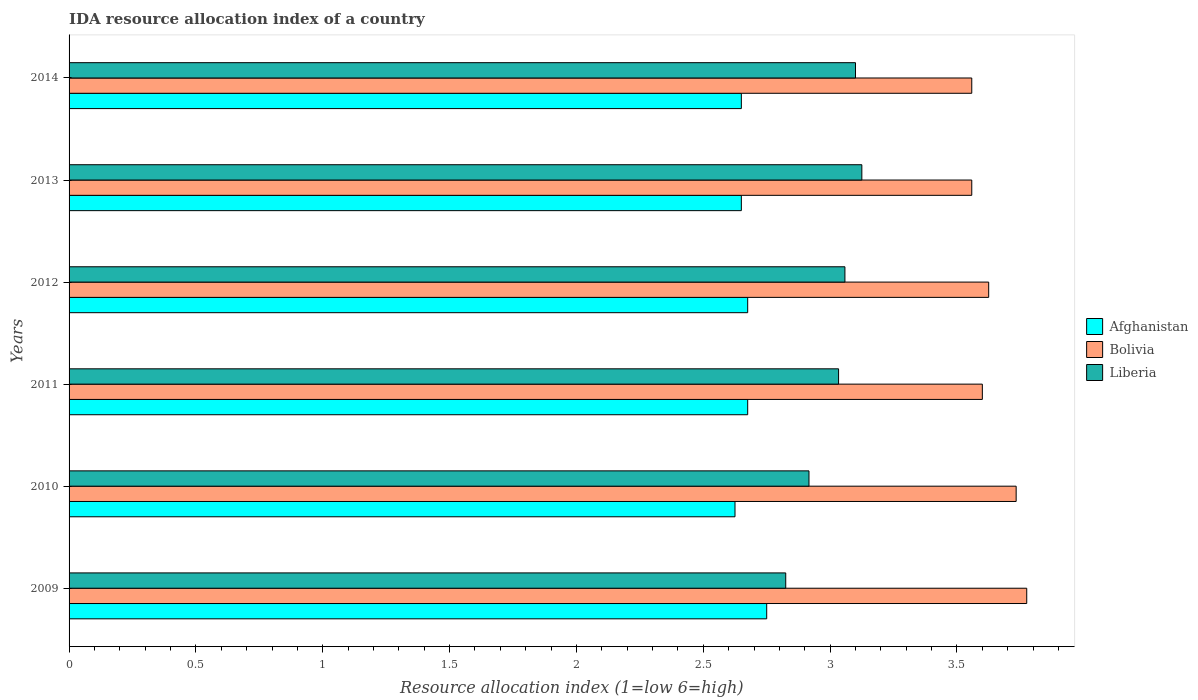How many different coloured bars are there?
Offer a terse response. 3. Are the number of bars per tick equal to the number of legend labels?
Make the answer very short. Yes. How many bars are there on the 2nd tick from the bottom?
Provide a short and direct response. 3. What is the label of the 1st group of bars from the top?
Offer a terse response. 2014. What is the IDA resource allocation index in Bolivia in 2009?
Give a very brief answer. 3.77. Across all years, what is the maximum IDA resource allocation index in Afghanistan?
Ensure brevity in your answer.  2.75. Across all years, what is the minimum IDA resource allocation index in Bolivia?
Your answer should be very brief. 3.56. In which year was the IDA resource allocation index in Bolivia maximum?
Make the answer very short. 2009. In which year was the IDA resource allocation index in Liberia minimum?
Make the answer very short. 2009. What is the total IDA resource allocation index in Liberia in the graph?
Provide a short and direct response. 18.06. What is the difference between the IDA resource allocation index in Afghanistan in 2009 and that in 2012?
Give a very brief answer. 0.08. What is the difference between the IDA resource allocation index in Liberia in 2014 and the IDA resource allocation index in Afghanistan in 2013?
Offer a terse response. 0.45. What is the average IDA resource allocation index in Bolivia per year?
Offer a terse response. 3.64. In the year 2014, what is the difference between the IDA resource allocation index in Liberia and IDA resource allocation index in Afghanistan?
Your response must be concise. 0.45. What is the ratio of the IDA resource allocation index in Liberia in 2011 to that in 2014?
Offer a very short reply. 0.98. Is the IDA resource allocation index in Bolivia in 2012 less than that in 2014?
Keep it short and to the point. No. What is the difference between the highest and the second highest IDA resource allocation index in Liberia?
Offer a terse response. 0.02. What is the difference between the highest and the lowest IDA resource allocation index in Bolivia?
Offer a terse response. 0.22. In how many years, is the IDA resource allocation index in Afghanistan greater than the average IDA resource allocation index in Afghanistan taken over all years?
Ensure brevity in your answer.  3. What does the 1st bar from the top in 2009 represents?
Ensure brevity in your answer.  Liberia. What does the 3rd bar from the bottom in 2013 represents?
Provide a succinct answer. Liberia. Is it the case that in every year, the sum of the IDA resource allocation index in Liberia and IDA resource allocation index in Afghanistan is greater than the IDA resource allocation index in Bolivia?
Your answer should be very brief. Yes. How many bars are there?
Keep it short and to the point. 18. How many years are there in the graph?
Provide a short and direct response. 6. Are the values on the major ticks of X-axis written in scientific E-notation?
Your answer should be compact. No. Does the graph contain any zero values?
Keep it short and to the point. No. Does the graph contain grids?
Ensure brevity in your answer.  No. Where does the legend appear in the graph?
Your answer should be compact. Center right. How are the legend labels stacked?
Offer a very short reply. Vertical. What is the title of the graph?
Keep it short and to the point. IDA resource allocation index of a country. Does "Switzerland" appear as one of the legend labels in the graph?
Provide a short and direct response. No. What is the label or title of the X-axis?
Make the answer very short. Resource allocation index (1=low 6=high). What is the Resource allocation index (1=low 6=high) in Afghanistan in 2009?
Keep it short and to the point. 2.75. What is the Resource allocation index (1=low 6=high) of Bolivia in 2009?
Your response must be concise. 3.77. What is the Resource allocation index (1=low 6=high) in Liberia in 2009?
Your answer should be very brief. 2.83. What is the Resource allocation index (1=low 6=high) of Afghanistan in 2010?
Provide a short and direct response. 2.62. What is the Resource allocation index (1=low 6=high) in Bolivia in 2010?
Your response must be concise. 3.73. What is the Resource allocation index (1=low 6=high) in Liberia in 2010?
Offer a terse response. 2.92. What is the Resource allocation index (1=low 6=high) of Afghanistan in 2011?
Keep it short and to the point. 2.67. What is the Resource allocation index (1=low 6=high) of Liberia in 2011?
Your response must be concise. 3.03. What is the Resource allocation index (1=low 6=high) of Afghanistan in 2012?
Provide a succinct answer. 2.67. What is the Resource allocation index (1=low 6=high) in Bolivia in 2012?
Provide a short and direct response. 3.62. What is the Resource allocation index (1=low 6=high) of Liberia in 2012?
Provide a succinct answer. 3.06. What is the Resource allocation index (1=low 6=high) in Afghanistan in 2013?
Provide a succinct answer. 2.65. What is the Resource allocation index (1=low 6=high) of Bolivia in 2013?
Offer a very short reply. 3.56. What is the Resource allocation index (1=low 6=high) of Liberia in 2013?
Give a very brief answer. 3.12. What is the Resource allocation index (1=low 6=high) of Afghanistan in 2014?
Provide a succinct answer. 2.65. What is the Resource allocation index (1=low 6=high) of Bolivia in 2014?
Your response must be concise. 3.56. Across all years, what is the maximum Resource allocation index (1=low 6=high) in Afghanistan?
Ensure brevity in your answer.  2.75. Across all years, what is the maximum Resource allocation index (1=low 6=high) in Bolivia?
Keep it short and to the point. 3.77. Across all years, what is the maximum Resource allocation index (1=low 6=high) in Liberia?
Offer a very short reply. 3.12. Across all years, what is the minimum Resource allocation index (1=low 6=high) in Afghanistan?
Your answer should be very brief. 2.62. Across all years, what is the minimum Resource allocation index (1=low 6=high) of Bolivia?
Keep it short and to the point. 3.56. Across all years, what is the minimum Resource allocation index (1=low 6=high) in Liberia?
Your response must be concise. 2.83. What is the total Resource allocation index (1=low 6=high) of Afghanistan in the graph?
Provide a short and direct response. 16.02. What is the total Resource allocation index (1=low 6=high) in Bolivia in the graph?
Offer a terse response. 21.85. What is the total Resource allocation index (1=low 6=high) in Liberia in the graph?
Provide a short and direct response. 18.06. What is the difference between the Resource allocation index (1=low 6=high) in Bolivia in 2009 and that in 2010?
Offer a terse response. 0.04. What is the difference between the Resource allocation index (1=low 6=high) of Liberia in 2009 and that in 2010?
Offer a terse response. -0.09. What is the difference between the Resource allocation index (1=low 6=high) in Afghanistan in 2009 and that in 2011?
Your answer should be compact. 0.07. What is the difference between the Resource allocation index (1=low 6=high) of Bolivia in 2009 and that in 2011?
Your answer should be very brief. 0.17. What is the difference between the Resource allocation index (1=low 6=high) in Liberia in 2009 and that in 2011?
Keep it short and to the point. -0.21. What is the difference between the Resource allocation index (1=low 6=high) in Afghanistan in 2009 and that in 2012?
Offer a very short reply. 0.07. What is the difference between the Resource allocation index (1=low 6=high) in Bolivia in 2009 and that in 2012?
Ensure brevity in your answer.  0.15. What is the difference between the Resource allocation index (1=low 6=high) in Liberia in 2009 and that in 2012?
Your answer should be very brief. -0.23. What is the difference between the Resource allocation index (1=low 6=high) in Afghanistan in 2009 and that in 2013?
Provide a succinct answer. 0.1. What is the difference between the Resource allocation index (1=low 6=high) in Bolivia in 2009 and that in 2013?
Your answer should be very brief. 0.22. What is the difference between the Resource allocation index (1=low 6=high) in Liberia in 2009 and that in 2013?
Offer a very short reply. -0.3. What is the difference between the Resource allocation index (1=low 6=high) in Bolivia in 2009 and that in 2014?
Your response must be concise. 0.22. What is the difference between the Resource allocation index (1=low 6=high) of Liberia in 2009 and that in 2014?
Offer a terse response. -0.28. What is the difference between the Resource allocation index (1=low 6=high) in Bolivia in 2010 and that in 2011?
Offer a very short reply. 0.13. What is the difference between the Resource allocation index (1=low 6=high) of Liberia in 2010 and that in 2011?
Your response must be concise. -0.12. What is the difference between the Resource allocation index (1=low 6=high) in Afghanistan in 2010 and that in 2012?
Your answer should be very brief. -0.05. What is the difference between the Resource allocation index (1=low 6=high) in Bolivia in 2010 and that in 2012?
Give a very brief answer. 0.11. What is the difference between the Resource allocation index (1=low 6=high) in Liberia in 2010 and that in 2012?
Keep it short and to the point. -0.14. What is the difference between the Resource allocation index (1=low 6=high) in Afghanistan in 2010 and that in 2013?
Offer a very short reply. -0.03. What is the difference between the Resource allocation index (1=low 6=high) in Bolivia in 2010 and that in 2013?
Give a very brief answer. 0.17. What is the difference between the Resource allocation index (1=low 6=high) in Liberia in 2010 and that in 2013?
Offer a terse response. -0.21. What is the difference between the Resource allocation index (1=low 6=high) of Afghanistan in 2010 and that in 2014?
Give a very brief answer. -0.03. What is the difference between the Resource allocation index (1=low 6=high) in Bolivia in 2010 and that in 2014?
Your answer should be very brief. 0.17. What is the difference between the Resource allocation index (1=low 6=high) in Liberia in 2010 and that in 2014?
Offer a very short reply. -0.18. What is the difference between the Resource allocation index (1=low 6=high) of Afghanistan in 2011 and that in 2012?
Keep it short and to the point. 0. What is the difference between the Resource allocation index (1=low 6=high) in Bolivia in 2011 and that in 2012?
Provide a succinct answer. -0.03. What is the difference between the Resource allocation index (1=low 6=high) in Liberia in 2011 and that in 2012?
Give a very brief answer. -0.03. What is the difference between the Resource allocation index (1=low 6=high) in Afghanistan in 2011 and that in 2013?
Ensure brevity in your answer.  0.03. What is the difference between the Resource allocation index (1=low 6=high) of Bolivia in 2011 and that in 2013?
Your answer should be very brief. 0.04. What is the difference between the Resource allocation index (1=low 6=high) in Liberia in 2011 and that in 2013?
Provide a short and direct response. -0.09. What is the difference between the Resource allocation index (1=low 6=high) in Afghanistan in 2011 and that in 2014?
Make the answer very short. 0.03. What is the difference between the Resource allocation index (1=low 6=high) in Bolivia in 2011 and that in 2014?
Give a very brief answer. 0.04. What is the difference between the Resource allocation index (1=low 6=high) of Liberia in 2011 and that in 2014?
Your answer should be very brief. -0.07. What is the difference between the Resource allocation index (1=low 6=high) of Afghanistan in 2012 and that in 2013?
Your response must be concise. 0.03. What is the difference between the Resource allocation index (1=low 6=high) of Bolivia in 2012 and that in 2013?
Your answer should be very brief. 0.07. What is the difference between the Resource allocation index (1=low 6=high) of Liberia in 2012 and that in 2013?
Keep it short and to the point. -0.07. What is the difference between the Resource allocation index (1=low 6=high) in Afghanistan in 2012 and that in 2014?
Your answer should be very brief. 0.03. What is the difference between the Resource allocation index (1=low 6=high) in Bolivia in 2012 and that in 2014?
Provide a succinct answer. 0.07. What is the difference between the Resource allocation index (1=low 6=high) of Liberia in 2012 and that in 2014?
Your answer should be compact. -0.04. What is the difference between the Resource allocation index (1=low 6=high) of Afghanistan in 2013 and that in 2014?
Give a very brief answer. 0. What is the difference between the Resource allocation index (1=low 6=high) in Liberia in 2013 and that in 2014?
Make the answer very short. 0.03. What is the difference between the Resource allocation index (1=low 6=high) in Afghanistan in 2009 and the Resource allocation index (1=low 6=high) in Bolivia in 2010?
Offer a terse response. -0.98. What is the difference between the Resource allocation index (1=low 6=high) of Afghanistan in 2009 and the Resource allocation index (1=low 6=high) of Liberia in 2010?
Your answer should be compact. -0.17. What is the difference between the Resource allocation index (1=low 6=high) in Bolivia in 2009 and the Resource allocation index (1=low 6=high) in Liberia in 2010?
Make the answer very short. 0.86. What is the difference between the Resource allocation index (1=low 6=high) in Afghanistan in 2009 and the Resource allocation index (1=low 6=high) in Bolivia in 2011?
Ensure brevity in your answer.  -0.85. What is the difference between the Resource allocation index (1=low 6=high) in Afghanistan in 2009 and the Resource allocation index (1=low 6=high) in Liberia in 2011?
Keep it short and to the point. -0.28. What is the difference between the Resource allocation index (1=low 6=high) in Bolivia in 2009 and the Resource allocation index (1=low 6=high) in Liberia in 2011?
Make the answer very short. 0.74. What is the difference between the Resource allocation index (1=low 6=high) in Afghanistan in 2009 and the Resource allocation index (1=low 6=high) in Bolivia in 2012?
Offer a terse response. -0.88. What is the difference between the Resource allocation index (1=low 6=high) of Afghanistan in 2009 and the Resource allocation index (1=low 6=high) of Liberia in 2012?
Provide a short and direct response. -0.31. What is the difference between the Resource allocation index (1=low 6=high) of Bolivia in 2009 and the Resource allocation index (1=low 6=high) of Liberia in 2012?
Provide a short and direct response. 0.72. What is the difference between the Resource allocation index (1=low 6=high) in Afghanistan in 2009 and the Resource allocation index (1=low 6=high) in Bolivia in 2013?
Offer a very short reply. -0.81. What is the difference between the Resource allocation index (1=low 6=high) of Afghanistan in 2009 and the Resource allocation index (1=low 6=high) of Liberia in 2013?
Keep it short and to the point. -0.38. What is the difference between the Resource allocation index (1=low 6=high) of Bolivia in 2009 and the Resource allocation index (1=low 6=high) of Liberia in 2013?
Your answer should be very brief. 0.65. What is the difference between the Resource allocation index (1=low 6=high) in Afghanistan in 2009 and the Resource allocation index (1=low 6=high) in Bolivia in 2014?
Your answer should be very brief. -0.81. What is the difference between the Resource allocation index (1=low 6=high) of Afghanistan in 2009 and the Resource allocation index (1=low 6=high) of Liberia in 2014?
Offer a very short reply. -0.35. What is the difference between the Resource allocation index (1=low 6=high) of Bolivia in 2009 and the Resource allocation index (1=low 6=high) of Liberia in 2014?
Your answer should be very brief. 0.68. What is the difference between the Resource allocation index (1=low 6=high) of Afghanistan in 2010 and the Resource allocation index (1=low 6=high) of Bolivia in 2011?
Provide a short and direct response. -0.97. What is the difference between the Resource allocation index (1=low 6=high) in Afghanistan in 2010 and the Resource allocation index (1=low 6=high) in Liberia in 2011?
Your answer should be very brief. -0.41. What is the difference between the Resource allocation index (1=low 6=high) in Bolivia in 2010 and the Resource allocation index (1=low 6=high) in Liberia in 2011?
Your answer should be compact. 0.7. What is the difference between the Resource allocation index (1=low 6=high) in Afghanistan in 2010 and the Resource allocation index (1=low 6=high) in Liberia in 2012?
Keep it short and to the point. -0.43. What is the difference between the Resource allocation index (1=low 6=high) in Bolivia in 2010 and the Resource allocation index (1=low 6=high) in Liberia in 2012?
Provide a short and direct response. 0.68. What is the difference between the Resource allocation index (1=low 6=high) in Afghanistan in 2010 and the Resource allocation index (1=low 6=high) in Bolivia in 2013?
Your answer should be very brief. -0.93. What is the difference between the Resource allocation index (1=low 6=high) in Afghanistan in 2010 and the Resource allocation index (1=low 6=high) in Liberia in 2013?
Provide a succinct answer. -0.5. What is the difference between the Resource allocation index (1=low 6=high) of Bolivia in 2010 and the Resource allocation index (1=low 6=high) of Liberia in 2013?
Your answer should be very brief. 0.61. What is the difference between the Resource allocation index (1=low 6=high) of Afghanistan in 2010 and the Resource allocation index (1=low 6=high) of Bolivia in 2014?
Make the answer very short. -0.93. What is the difference between the Resource allocation index (1=low 6=high) in Afghanistan in 2010 and the Resource allocation index (1=low 6=high) in Liberia in 2014?
Your answer should be compact. -0.47. What is the difference between the Resource allocation index (1=low 6=high) of Bolivia in 2010 and the Resource allocation index (1=low 6=high) of Liberia in 2014?
Your answer should be very brief. 0.63. What is the difference between the Resource allocation index (1=low 6=high) in Afghanistan in 2011 and the Resource allocation index (1=low 6=high) in Bolivia in 2012?
Offer a very short reply. -0.95. What is the difference between the Resource allocation index (1=low 6=high) in Afghanistan in 2011 and the Resource allocation index (1=low 6=high) in Liberia in 2012?
Offer a very short reply. -0.38. What is the difference between the Resource allocation index (1=low 6=high) in Bolivia in 2011 and the Resource allocation index (1=low 6=high) in Liberia in 2012?
Keep it short and to the point. 0.54. What is the difference between the Resource allocation index (1=low 6=high) of Afghanistan in 2011 and the Resource allocation index (1=low 6=high) of Bolivia in 2013?
Your response must be concise. -0.88. What is the difference between the Resource allocation index (1=low 6=high) in Afghanistan in 2011 and the Resource allocation index (1=low 6=high) in Liberia in 2013?
Offer a terse response. -0.45. What is the difference between the Resource allocation index (1=low 6=high) in Bolivia in 2011 and the Resource allocation index (1=low 6=high) in Liberia in 2013?
Ensure brevity in your answer.  0.47. What is the difference between the Resource allocation index (1=low 6=high) in Afghanistan in 2011 and the Resource allocation index (1=low 6=high) in Bolivia in 2014?
Ensure brevity in your answer.  -0.88. What is the difference between the Resource allocation index (1=low 6=high) of Afghanistan in 2011 and the Resource allocation index (1=low 6=high) of Liberia in 2014?
Keep it short and to the point. -0.42. What is the difference between the Resource allocation index (1=low 6=high) in Afghanistan in 2012 and the Resource allocation index (1=low 6=high) in Bolivia in 2013?
Make the answer very short. -0.88. What is the difference between the Resource allocation index (1=low 6=high) of Afghanistan in 2012 and the Resource allocation index (1=low 6=high) of Liberia in 2013?
Offer a very short reply. -0.45. What is the difference between the Resource allocation index (1=low 6=high) of Bolivia in 2012 and the Resource allocation index (1=low 6=high) of Liberia in 2013?
Your response must be concise. 0.5. What is the difference between the Resource allocation index (1=low 6=high) in Afghanistan in 2012 and the Resource allocation index (1=low 6=high) in Bolivia in 2014?
Make the answer very short. -0.88. What is the difference between the Resource allocation index (1=low 6=high) of Afghanistan in 2012 and the Resource allocation index (1=low 6=high) of Liberia in 2014?
Your answer should be very brief. -0.42. What is the difference between the Resource allocation index (1=low 6=high) of Bolivia in 2012 and the Resource allocation index (1=low 6=high) of Liberia in 2014?
Ensure brevity in your answer.  0.53. What is the difference between the Resource allocation index (1=low 6=high) in Afghanistan in 2013 and the Resource allocation index (1=low 6=high) in Bolivia in 2014?
Offer a terse response. -0.91. What is the difference between the Resource allocation index (1=low 6=high) of Afghanistan in 2013 and the Resource allocation index (1=low 6=high) of Liberia in 2014?
Ensure brevity in your answer.  -0.45. What is the difference between the Resource allocation index (1=low 6=high) of Bolivia in 2013 and the Resource allocation index (1=low 6=high) of Liberia in 2014?
Provide a succinct answer. 0.46. What is the average Resource allocation index (1=low 6=high) in Afghanistan per year?
Offer a very short reply. 2.67. What is the average Resource allocation index (1=low 6=high) in Bolivia per year?
Provide a short and direct response. 3.64. What is the average Resource allocation index (1=low 6=high) in Liberia per year?
Ensure brevity in your answer.  3.01. In the year 2009, what is the difference between the Resource allocation index (1=low 6=high) in Afghanistan and Resource allocation index (1=low 6=high) in Bolivia?
Ensure brevity in your answer.  -1.02. In the year 2009, what is the difference between the Resource allocation index (1=low 6=high) in Afghanistan and Resource allocation index (1=low 6=high) in Liberia?
Keep it short and to the point. -0.07. In the year 2010, what is the difference between the Resource allocation index (1=low 6=high) in Afghanistan and Resource allocation index (1=low 6=high) in Bolivia?
Give a very brief answer. -1.11. In the year 2010, what is the difference between the Resource allocation index (1=low 6=high) of Afghanistan and Resource allocation index (1=low 6=high) of Liberia?
Provide a short and direct response. -0.29. In the year 2010, what is the difference between the Resource allocation index (1=low 6=high) in Bolivia and Resource allocation index (1=low 6=high) in Liberia?
Offer a very short reply. 0.82. In the year 2011, what is the difference between the Resource allocation index (1=low 6=high) of Afghanistan and Resource allocation index (1=low 6=high) of Bolivia?
Ensure brevity in your answer.  -0.93. In the year 2011, what is the difference between the Resource allocation index (1=low 6=high) of Afghanistan and Resource allocation index (1=low 6=high) of Liberia?
Your response must be concise. -0.36. In the year 2011, what is the difference between the Resource allocation index (1=low 6=high) in Bolivia and Resource allocation index (1=low 6=high) in Liberia?
Give a very brief answer. 0.57. In the year 2012, what is the difference between the Resource allocation index (1=low 6=high) of Afghanistan and Resource allocation index (1=low 6=high) of Bolivia?
Ensure brevity in your answer.  -0.95. In the year 2012, what is the difference between the Resource allocation index (1=low 6=high) of Afghanistan and Resource allocation index (1=low 6=high) of Liberia?
Provide a short and direct response. -0.38. In the year 2012, what is the difference between the Resource allocation index (1=low 6=high) of Bolivia and Resource allocation index (1=low 6=high) of Liberia?
Your response must be concise. 0.57. In the year 2013, what is the difference between the Resource allocation index (1=low 6=high) in Afghanistan and Resource allocation index (1=low 6=high) in Bolivia?
Offer a terse response. -0.91. In the year 2013, what is the difference between the Resource allocation index (1=low 6=high) in Afghanistan and Resource allocation index (1=low 6=high) in Liberia?
Make the answer very short. -0.47. In the year 2013, what is the difference between the Resource allocation index (1=low 6=high) of Bolivia and Resource allocation index (1=low 6=high) of Liberia?
Your response must be concise. 0.43. In the year 2014, what is the difference between the Resource allocation index (1=low 6=high) of Afghanistan and Resource allocation index (1=low 6=high) of Bolivia?
Give a very brief answer. -0.91. In the year 2014, what is the difference between the Resource allocation index (1=low 6=high) in Afghanistan and Resource allocation index (1=low 6=high) in Liberia?
Give a very brief answer. -0.45. In the year 2014, what is the difference between the Resource allocation index (1=low 6=high) in Bolivia and Resource allocation index (1=low 6=high) in Liberia?
Ensure brevity in your answer.  0.46. What is the ratio of the Resource allocation index (1=low 6=high) of Afghanistan in 2009 to that in 2010?
Make the answer very short. 1.05. What is the ratio of the Resource allocation index (1=low 6=high) of Bolivia in 2009 to that in 2010?
Provide a succinct answer. 1.01. What is the ratio of the Resource allocation index (1=low 6=high) of Liberia in 2009 to that in 2010?
Offer a terse response. 0.97. What is the ratio of the Resource allocation index (1=low 6=high) in Afghanistan in 2009 to that in 2011?
Offer a very short reply. 1.03. What is the ratio of the Resource allocation index (1=low 6=high) in Bolivia in 2009 to that in 2011?
Keep it short and to the point. 1.05. What is the ratio of the Resource allocation index (1=low 6=high) of Liberia in 2009 to that in 2011?
Offer a very short reply. 0.93. What is the ratio of the Resource allocation index (1=low 6=high) in Afghanistan in 2009 to that in 2012?
Provide a succinct answer. 1.03. What is the ratio of the Resource allocation index (1=low 6=high) in Bolivia in 2009 to that in 2012?
Your answer should be compact. 1.04. What is the ratio of the Resource allocation index (1=low 6=high) in Liberia in 2009 to that in 2012?
Provide a succinct answer. 0.92. What is the ratio of the Resource allocation index (1=low 6=high) of Afghanistan in 2009 to that in 2013?
Offer a very short reply. 1.04. What is the ratio of the Resource allocation index (1=low 6=high) of Bolivia in 2009 to that in 2013?
Give a very brief answer. 1.06. What is the ratio of the Resource allocation index (1=low 6=high) in Liberia in 2009 to that in 2013?
Offer a very short reply. 0.9. What is the ratio of the Resource allocation index (1=low 6=high) of Afghanistan in 2009 to that in 2014?
Your answer should be very brief. 1.04. What is the ratio of the Resource allocation index (1=low 6=high) of Bolivia in 2009 to that in 2014?
Ensure brevity in your answer.  1.06. What is the ratio of the Resource allocation index (1=low 6=high) in Liberia in 2009 to that in 2014?
Keep it short and to the point. 0.91. What is the ratio of the Resource allocation index (1=low 6=high) of Afghanistan in 2010 to that in 2011?
Ensure brevity in your answer.  0.98. What is the ratio of the Resource allocation index (1=low 6=high) in Liberia in 2010 to that in 2011?
Your response must be concise. 0.96. What is the ratio of the Resource allocation index (1=low 6=high) of Afghanistan in 2010 to that in 2012?
Your answer should be compact. 0.98. What is the ratio of the Resource allocation index (1=low 6=high) in Bolivia in 2010 to that in 2012?
Offer a very short reply. 1.03. What is the ratio of the Resource allocation index (1=low 6=high) of Liberia in 2010 to that in 2012?
Your answer should be compact. 0.95. What is the ratio of the Resource allocation index (1=low 6=high) of Afghanistan in 2010 to that in 2013?
Your answer should be very brief. 0.99. What is the ratio of the Resource allocation index (1=low 6=high) of Bolivia in 2010 to that in 2013?
Make the answer very short. 1.05. What is the ratio of the Resource allocation index (1=low 6=high) of Afghanistan in 2010 to that in 2014?
Offer a terse response. 0.99. What is the ratio of the Resource allocation index (1=low 6=high) of Bolivia in 2010 to that in 2014?
Offer a very short reply. 1.05. What is the ratio of the Resource allocation index (1=low 6=high) in Liberia in 2010 to that in 2014?
Provide a short and direct response. 0.94. What is the ratio of the Resource allocation index (1=low 6=high) in Afghanistan in 2011 to that in 2012?
Provide a succinct answer. 1. What is the ratio of the Resource allocation index (1=low 6=high) of Liberia in 2011 to that in 2012?
Provide a short and direct response. 0.99. What is the ratio of the Resource allocation index (1=low 6=high) in Afghanistan in 2011 to that in 2013?
Provide a succinct answer. 1.01. What is the ratio of the Resource allocation index (1=low 6=high) in Bolivia in 2011 to that in 2013?
Ensure brevity in your answer.  1.01. What is the ratio of the Resource allocation index (1=low 6=high) of Liberia in 2011 to that in 2013?
Provide a short and direct response. 0.97. What is the ratio of the Resource allocation index (1=low 6=high) of Afghanistan in 2011 to that in 2014?
Your answer should be compact. 1.01. What is the ratio of the Resource allocation index (1=low 6=high) in Bolivia in 2011 to that in 2014?
Your answer should be compact. 1.01. What is the ratio of the Resource allocation index (1=low 6=high) of Liberia in 2011 to that in 2014?
Offer a very short reply. 0.98. What is the ratio of the Resource allocation index (1=low 6=high) in Afghanistan in 2012 to that in 2013?
Give a very brief answer. 1.01. What is the ratio of the Resource allocation index (1=low 6=high) of Bolivia in 2012 to that in 2013?
Offer a terse response. 1.02. What is the ratio of the Resource allocation index (1=low 6=high) of Liberia in 2012 to that in 2013?
Ensure brevity in your answer.  0.98. What is the ratio of the Resource allocation index (1=low 6=high) in Afghanistan in 2012 to that in 2014?
Provide a succinct answer. 1.01. What is the ratio of the Resource allocation index (1=low 6=high) in Bolivia in 2012 to that in 2014?
Offer a terse response. 1.02. What is the ratio of the Resource allocation index (1=low 6=high) of Liberia in 2012 to that in 2014?
Offer a very short reply. 0.99. What is the ratio of the Resource allocation index (1=low 6=high) in Bolivia in 2013 to that in 2014?
Keep it short and to the point. 1. What is the ratio of the Resource allocation index (1=low 6=high) in Liberia in 2013 to that in 2014?
Your response must be concise. 1.01. What is the difference between the highest and the second highest Resource allocation index (1=low 6=high) in Afghanistan?
Provide a short and direct response. 0.07. What is the difference between the highest and the second highest Resource allocation index (1=low 6=high) in Bolivia?
Ensure brevity in your answer.  0.04. What is the difference between the highest and the second highest Resource allocation index (1=low 6=high) of Liberia?
Offer a very short reply. 0.03. What is the difference between the highest and the lowest Resource allocation index (1=low 6=high) in Afghanistan?
Provide a short and direct response. 0.12. What is the difference between the highest and the lowest Resource allocation index (1=low 6=high) of Bolivia?
Make the answer very short. 0.22. What is the difference between the highest and the lowest Resource allocation index (1=low 6=high) in Liberia?
Provide a short and direct response. 0.3. 